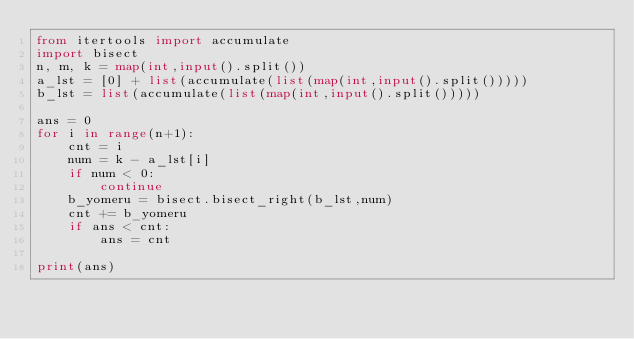<code> <loc_0><loc_0><loc_500><loc_500><_Python_>from itertools import accumulate
import bisect
n, m, k = map(int,input().split())
a_lst = [0] + list(accumulate(list(map(int,input().split()))))
b_lst = list(accumulate(list(map(int,input().split()))))

ans = 0
for i in range(n+1):
    cnt = i
    num = k - a_lst[i]
    if num < 0:
        continue
    b_yomeru = bisect.bisect_right(b_lst,num)
    cnt += b_yomeru
    if ans < cnt:
        ans = cnt

print(ans)
</code> 